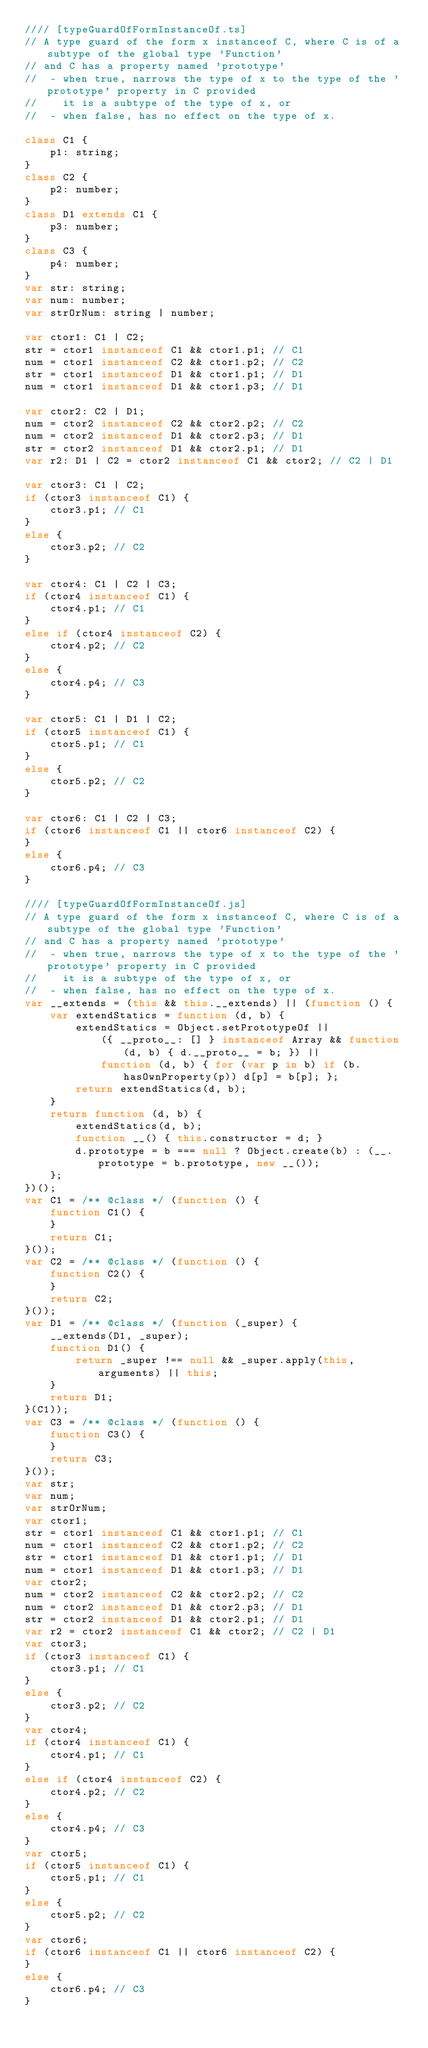Convert code to text. <code><loc_0><loc_0><loc_500><loc_500><_JavaScript_>//// [typeGuardOfFormInstanceOf.ts]
// A type guard of the form x instanceof C, where C is of a subtype of the global type 'Function' 
// and C has a property named 'prototype'
//  - when true, narrows the type of x to the type of the 'prototype' property in C provided 
//    it is a subtype of the type of x, or
//  - when false, has no effect on the type of x.

class C1 {
    p1: string;
}
class C2 {
    p2: number;
}
class D1 extends C1 {
    p3: number;
}
class C3 {
    p4: number;
}
var str: string;
var num: number;
var strOrNum: string | number;

var ctor1: C1 | C2;
str = ctor1 instanceof C1 && ctor1.p1; // C1
num = ctor1 instanceof C2 && ctor1.p2; // C2
str = ctor1 instanceof D1 && ctor1.p1; // D1
num = ctor1 instanceof D1 && ctor1.p3; // D1

var ctor2: C2 | D1;
num = ctor2 instanceof C2 && ctor2.p2; // C2
num = ctor2 instanceof D1 && ctor2.p3; // D1
str = ctor2 instanceof D1 && ctor2.p1; // D1
var r2: D1 | C2 = ctor2 instanceof C1 && ctor2; // C2 | D1

var ctor3: C1 | C2;
if (ctor3 instanceof C1) {
    ctor3.p1; // C1
}
else {
    ctor3.p2; // C2
}

var ctor4: C1 | C2 | C3;
if (ctor4 instanceof C1) {
    ctor4.p1; // C1
}
else if (ctor4 instanceof C2) {
    ctor4.p2; // C2
}
else {
    ctor4.p4; // C3
}

var ctor5: C1 | D1 | C2;
if (ctor5 instanceof C1) {
    ctor5.p1; // C1
}
else {
    ctor5.p2; // C2
}

var ctor6: C1 | C2 | C3;
if (ctor6 instanceof C1 || ctor6 instanceof C2) {
}
else {
    ctor6.p4; // C3
}

//// [typeGuardOfFormInstanceOf.js]
// A type guard of the form x instanceof C, where C is of a subtype of the global type 'Function' 
// and C has a property named 'prototype'
//  - when true, narrows the type of x to the type of the 'prototype' property in C provided 
//    it is a subtype of the type of x, or
//  - when false, has no effect on the type of x.
var __extends = (this && this.__extends) || (function () {
    var extendStatics = function (d, b) {
        extendStatics = Object.setPrototypeOf ||
            ({ __proto__: [] } instanceof Array && function (d, b) { d.__proto__ = b; }) ||
            function (d, b) { for (var p in b) if (b.hasOwnProperty(p)) d[p] = b[p]; };
        return extendStatics(d, b);
    }
    return function (d, b) {
        extendStatics(d, b);
        function __() { this.constructor = d; }
        d.prototype = b === null ? Object.create(b) : (__.prototype = b.prototype, new __());
    };
})();
var C1 = /** @class */ (function () {
    function C1() {
    }
    return C1;
}());
var C2 = /** @class */ (function () {
    function C2() {
    }
    return C2;
}());
var D1 = /** @class */ (function (_super) {
    __extends(D1, _super);
    function D1() {
        return _super !== null && _super.apply(this, arguments) || this;
    }
    return D1;
}(C1));
var C3 = /** @class */ (function () {
    function C3() {
    }
    return C3;
}());
var str;
var num;
var strOrNum;
var ctor1;
str = ctor1 instanceof C1 && ctor1.p1; // C1
num = ctor1 instanceof C2 && ctor1.p2; // C2
str = ctor1 instanceof D1 && ctor1.p1; // D1
num = ctor1 instanceof D1 && ctor1.p3; // D1
var ctor2;
num = ctor2 instanceof C2 && ctor2.p2; // C2
num = ctor2 instanceof D1 && ctor2.p3; // D1
str = ctor2 instanceof D1 && ctor2.p1; // D1
var r2 = ctor2 instanceof C1 && ctor2; // C2 | D1
var ctor3;
if (ctor3 instanceof C1) {
    ctor3.p1; // C1
}
else {
    ctor3.p2; // C2
}
var ctor4;
if (ctor4 instanceof C1) {
    ctor4.p1; // C1
}
else if (ctor4 instanceof C2) {
    ctor4.p2; // C2
}
else {
    ctor4.p4; // C3
}
var ctor5;
if (ctor5 instanceof C1) {
    ctor5.p1; // C1
}
else {
    ctor5.p2; // C2
}
var ctor6;
if (ctor6 instanceof C1 || ctor6 instanceof C2) {
}
else {
    ctor6.p4; // C3
}
</code> 